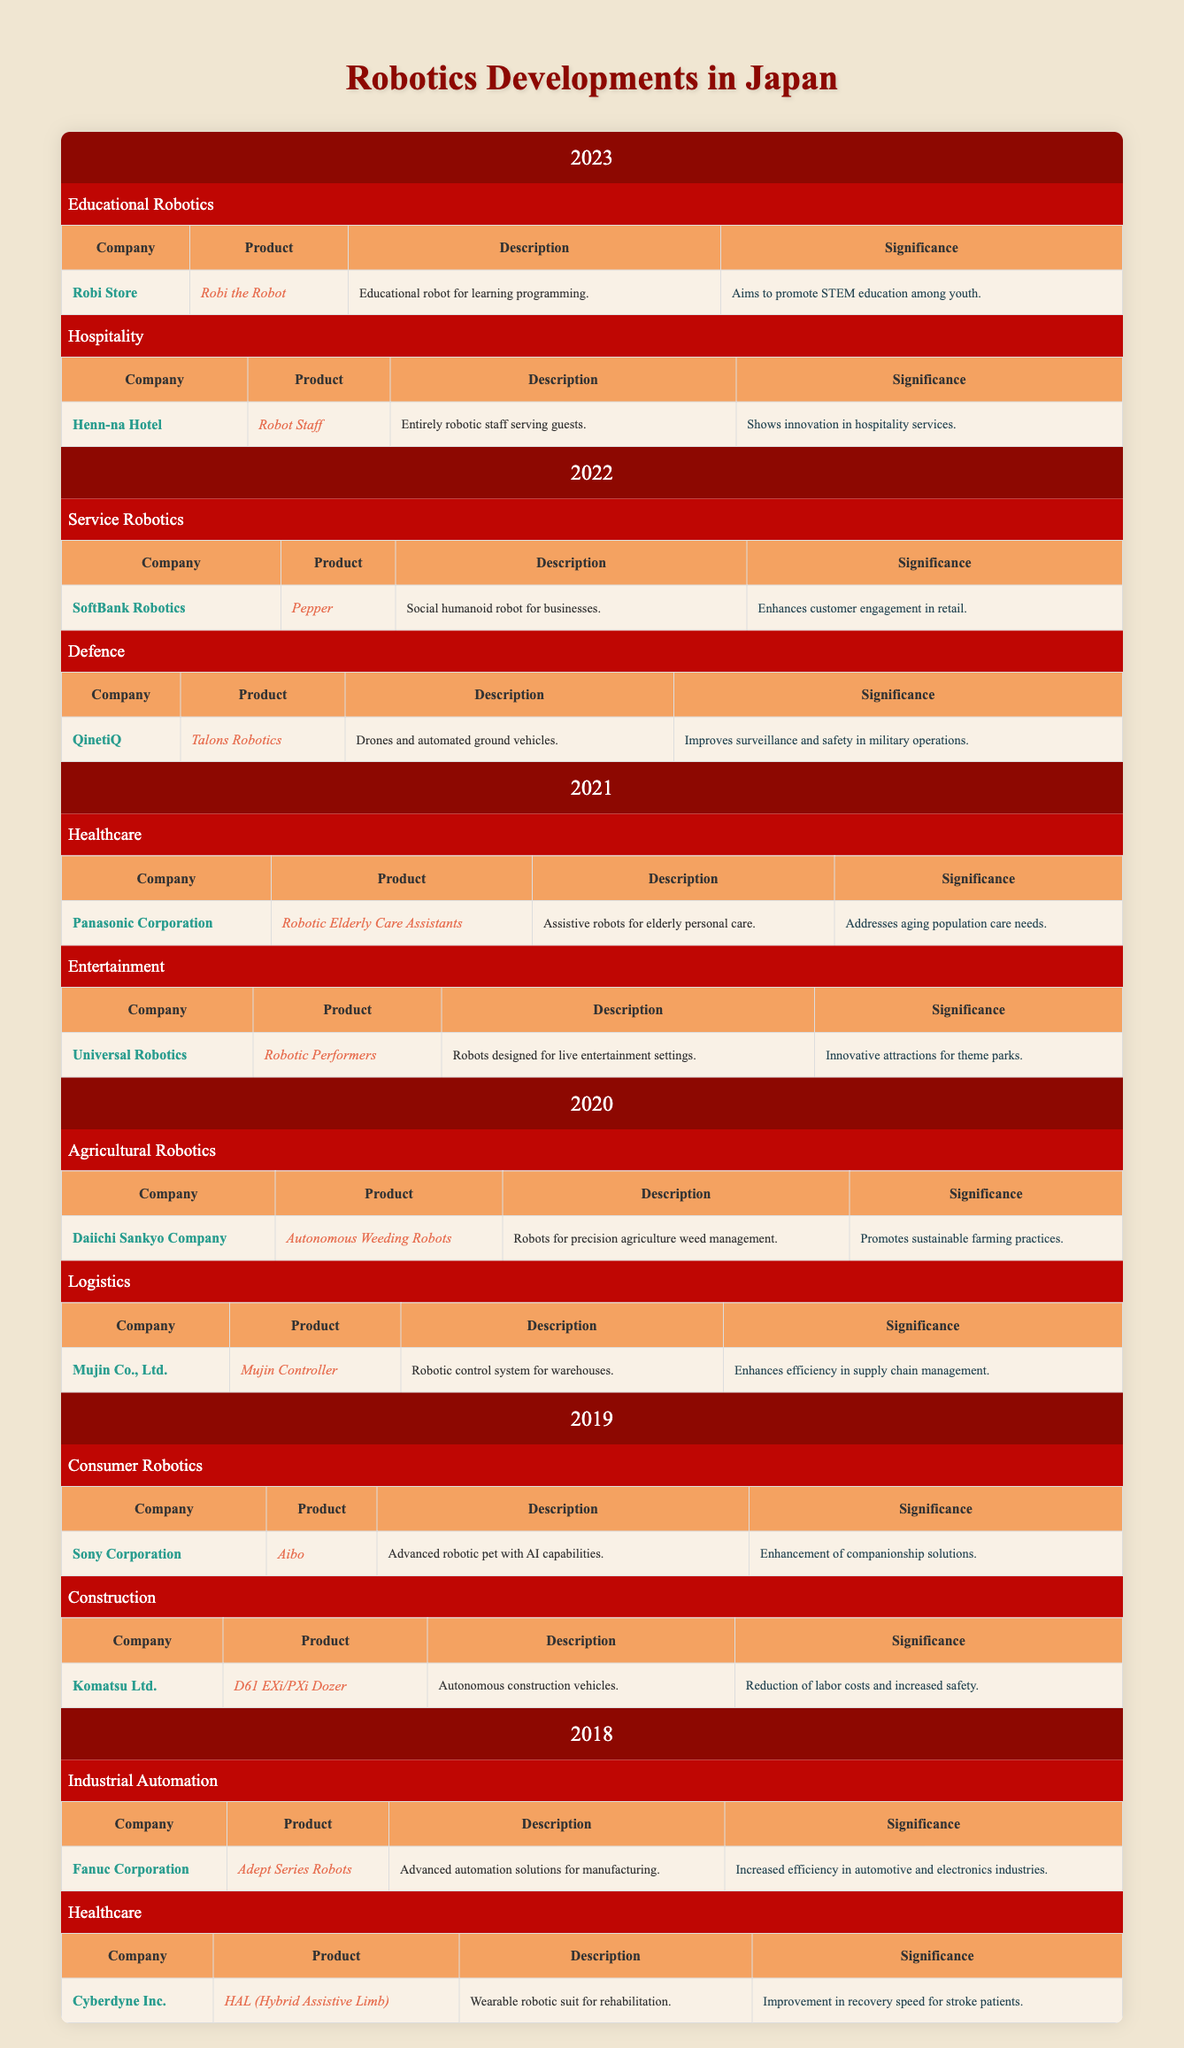What company developed the HAL (Hybrid Assistive Limb) in 2018? The table lists "Cyberdyne Inc." as the company that developed the HAL (Hybrid Assistive Limb) under the Healthcare category for the year 2018.
Answer: Cyberdyne Inc Which product was released by Fanuc Corporation and what was its significance? Fanuc Corporation released the "Adept Series Robots" in the Industrial Automation category in 2018, and its significance was "Increased efficiency in automotive and electronics industries."
Answer: Adept Series Robots; Increased efficiency in automotive and electronics industries How many different industry applications are represented in 2021? The table shows two industry applications in 2021: Healthcare and Entertainment. Thus, the count is 2.
Answer: 2 Did Sony Corporation release any robotics product for healthcare? Referring to the table, Sony Corporation released the "Aibo" in 2019, under Consumer Robotics, and there is no healthcare product listed for Sony Corporation; hence the answer is no.
Answer: No Which company's product aims to promote STEM education among youth, and when was it introduced? The product "Robi the Robot," developed by Robi Store, aims to promote STEM education. It was introduced in the year 2023 as listed under Educational Robotics.
Answer: Robi Store; 2023 In which year did Komatsu Ltd. introduce their autonomous construction vehicle? According to the table, Komatsu Ltd. introduced their "D61 EXi/PXi Dozer" in 2019, under the Construction category.
Answer: 2019 What is the significance of the "Mujin Controller" product, and which company produced it? The Mujin Controller was produced by Mujin Co., Ltd., and its significance is that it "Enhances efficiency in supply chain management" as stated in the Logistics category for the year 2020.
Answer: Mujin Co., Ltd.; Enhances efficiency in supply chain management How many products focused on the Healthcare industry were launched between 2018 and 2021? In the table, there are three healthcare products: HAL (2018), Robotic Elderly Care Assistants (2021), making the total 2 healthcare products launched during this time period.
Answer: 2 Which year saw the release of a product aimed at improving customer engagement in retail? Referring to the table, the "Pepper" robot by SoftBank Robotics, which enhances customer engagement in retail, was released in 2022.
Answer: 2022 